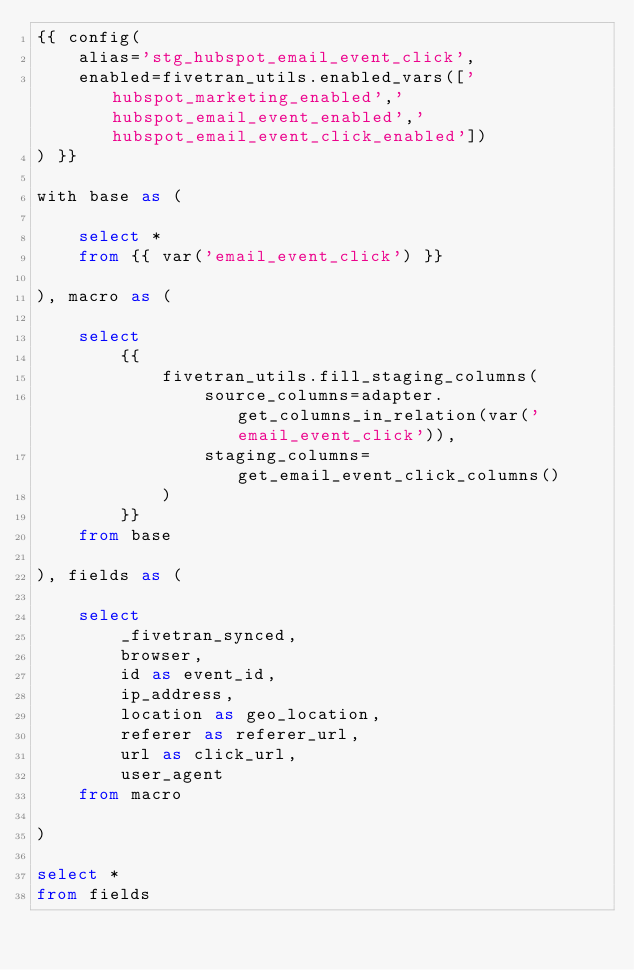Convert code to text. <code><loc_0><loc_0><loc_500><loc_500><_SQL_>{{ config(
    alias='stg_hubspot_email_event_click',
    enabled=fivetran_utils.enabled_vars(['hubspot_marketing_enabled','hubspot_email_event_enabled','hubspot_email_event_click_enabled'])
) }}

with base as (

    select *
    from {{ var('email_event_click') }}

), macro as (

    select
        {{
            fivetran_utils.fill_staging_columns(
                source_columns=adapter.get_columns_in_relation(var('email_event_click')),
                staging_columns=get_email_event_click_columns()
            )
        }}
    from base

), fields as (

    select
        _fivetran_synced,
        browser,
        id as event_id,
        ip_address,
        location as geo_location,
        referer as referer_url,
        url as click_url,
        user_agent
    from macro

)

select *
from fields
</code> 